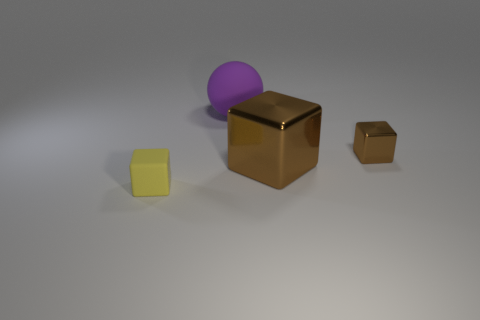Subtract 1 cubes. How many cubes are left? 2 Add 4 cubes. How many objects exist? 8 Subtract all blocks. How many objects are left? 1 Add 1 large rubber spheres. How many large rubber spheres exist? 2 Subtract 0 green balls. How many objects are left? 4 Subtract all brown metal things. Subtract all large brown objects. How many objects are left? 1 Add 1 yellow blocks. How many yellow blocks are left? 2 